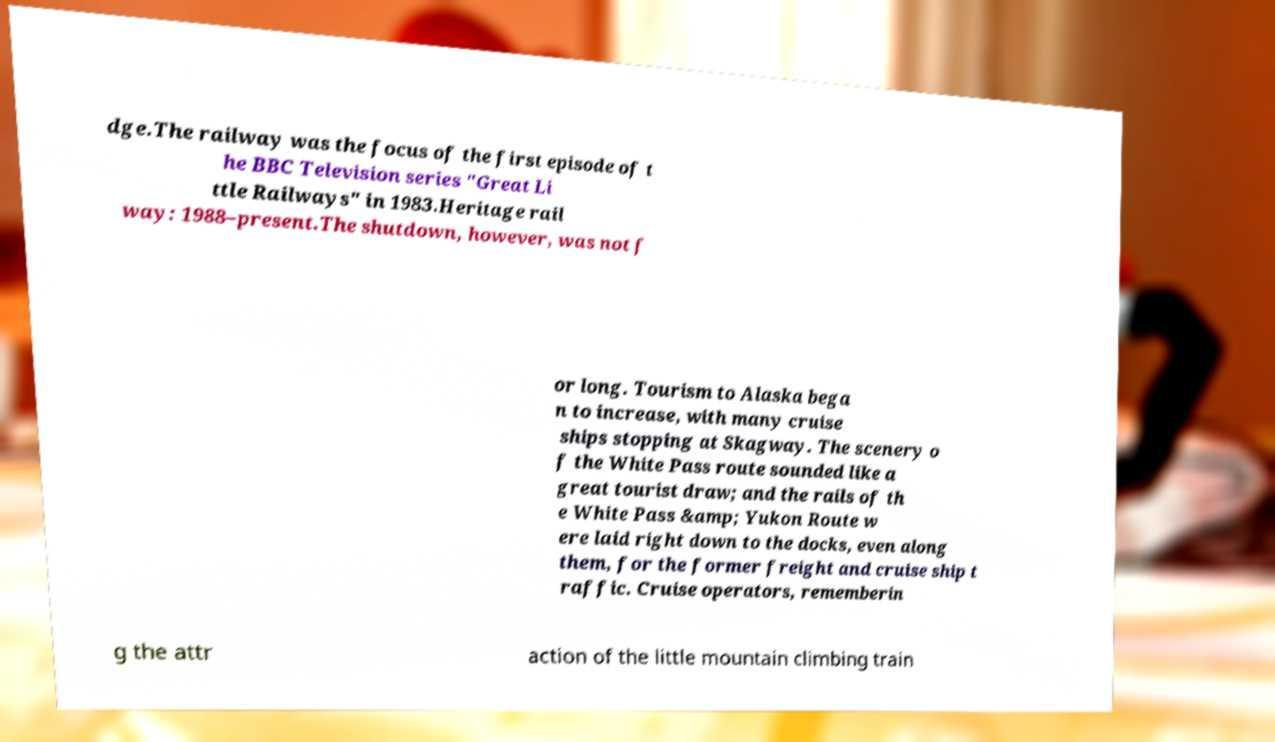Can you read and provide the text displayed in the image?This photo seems to have some interesting text. Can you extract and type it out for me? dge.The railway was the focus of the first episode of t he BBC Television series "Great Li ttle Railways" in 1983.Heritage rail way: 1988–present.The shutdown, however, was not f or long. Tourism to Alaska bega n to increase, with many cruise ships stopping at Skagway. The scenery o f the White Pass route sounded like a great tourist draw; and the rails of th e White Pass &amp; Yukon Route w ere laid right down to the docks, even along them, for the former freight and cruise ship t raffic. Cruise operators, rememberin g the attr action of the little mountain climbing train 